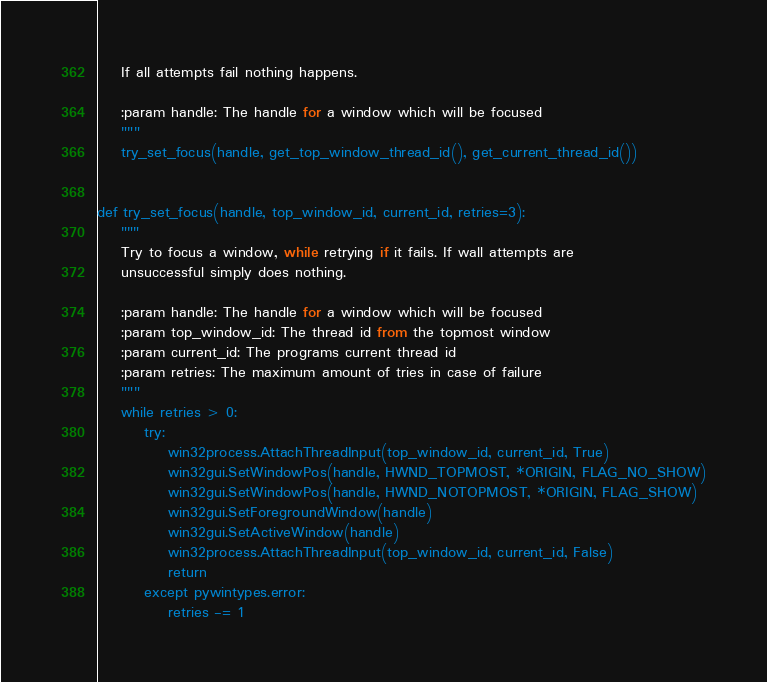Convert code to text. <code><loc_0><loc_0><loc_500><loc_500><_Python_>    If all attempts fail nothing happens.

    :param handle: The handle for a window which will be focused
    """
    try_set_focus(handle, get_top_window_thread_id(), get_current_thread_id())


def try_set_focus(handle, top_window_id, current_id, retries=3):
    """
    Try to focus a window, while retrying if it fails. If wall attempts are
    unsuccessful simply does nothing.

    :param handle: The handle for a window which will be focused
    :param top_window_id: The thread id from the topmost window
    :param current_id: The programs current thread id
    :param retries: The maximum amount of tries in case of failure
    """
    while retries > 0:
        try:
            win32process.AttachThreadInput(top_window_id, current_id, True)
            win32gui.SetWindowPos(handle, HWND_TOPMOST, *ORIGIN, FLAG_NO_SHOW)
            win32gui.SetWindowPos(handle, HWND_NOTOPMOST, *ORIGIN, FLAG_SHOW)
            win32gui.SetForegroundWindow(handle)
            win32gui.SetActiveWindow(handle)
            win32process.AttachThreadInput(top_window_id, current_id, False)
            return
        except pywintypes.error:
            retries -= 1
</code> 